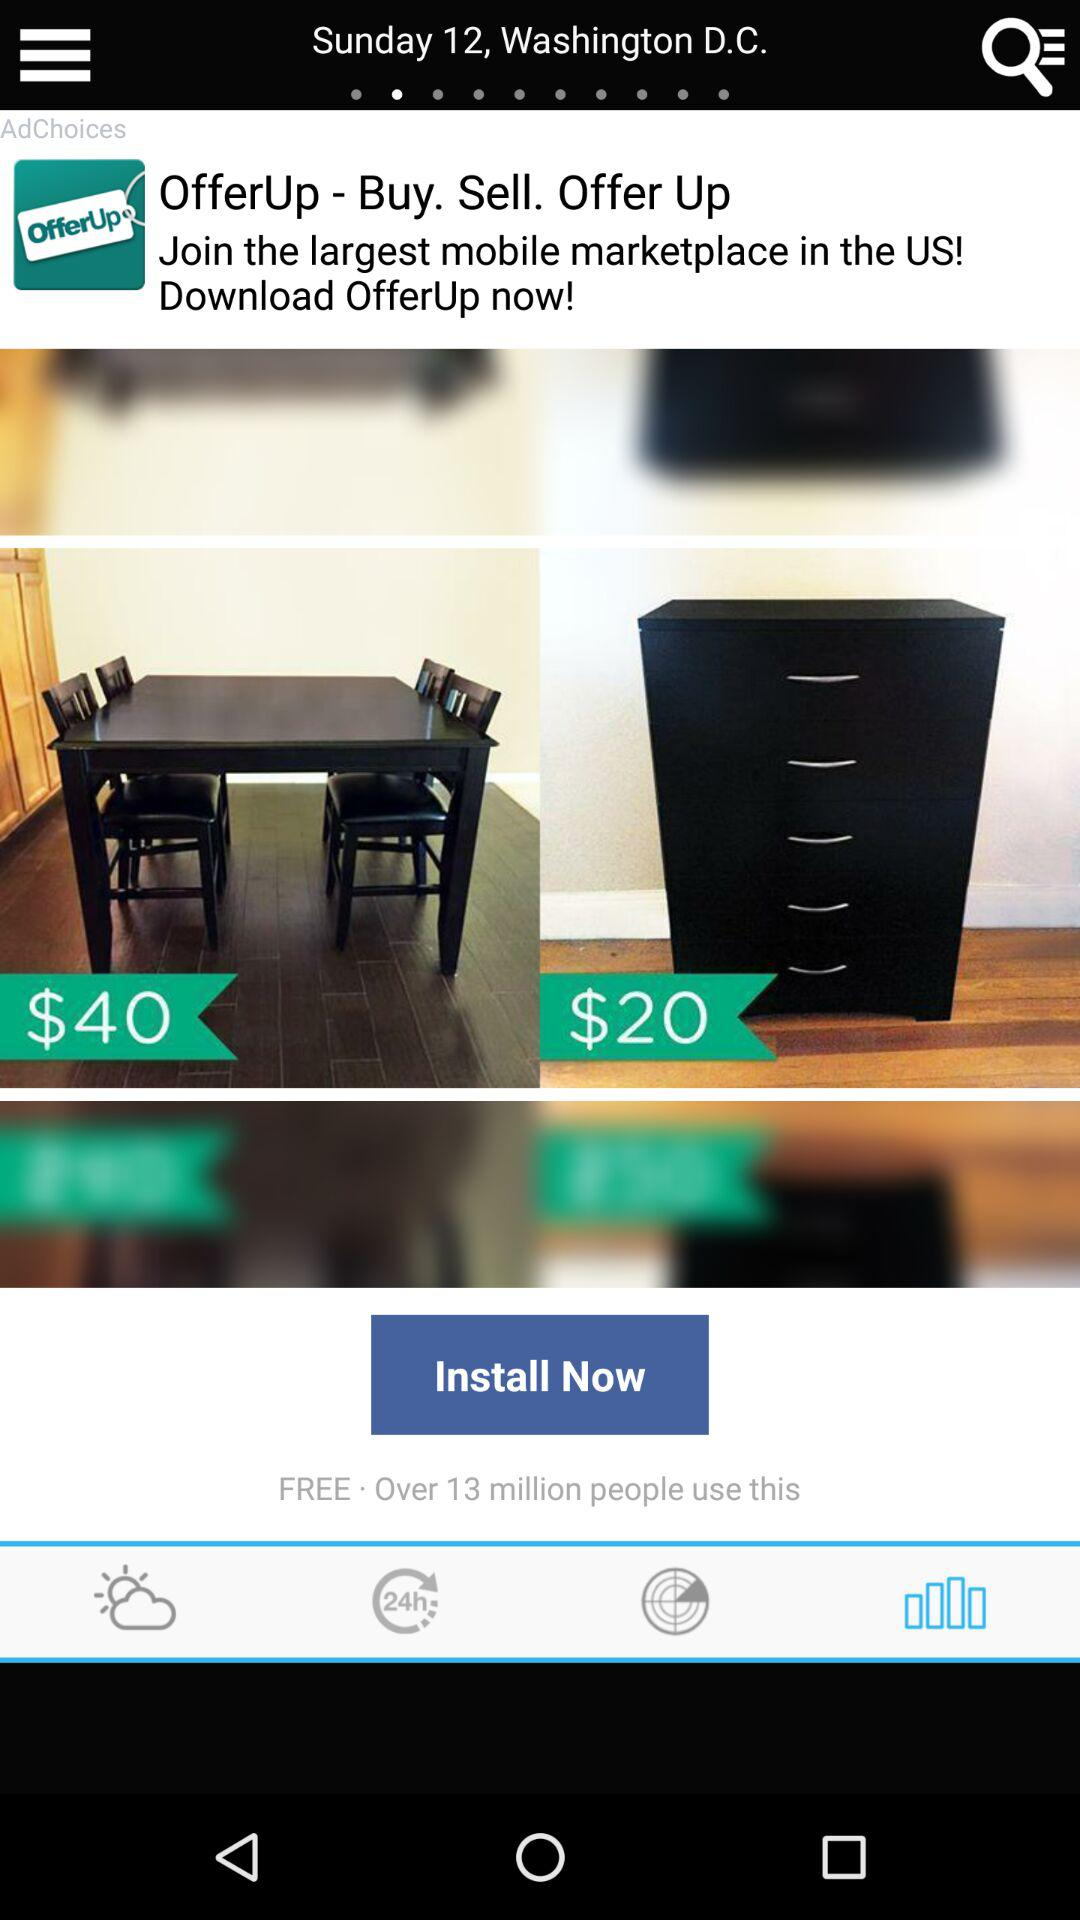How many items have a price tag?
Answer the question using a single word or phrase. 2 